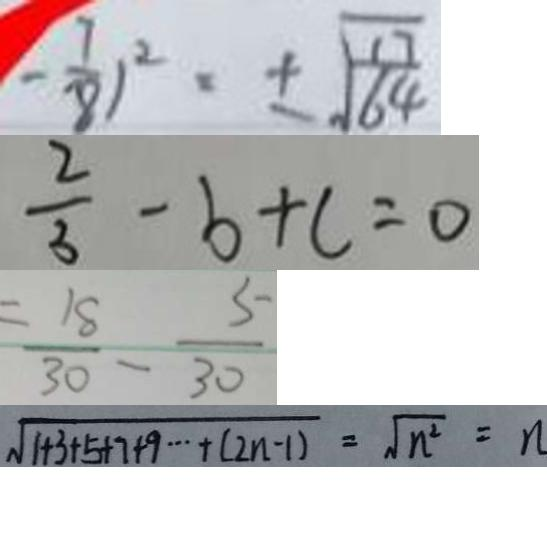<formula> <loc_0><loc_0><loc_500><loc_500>- \frac { 7 } { 8 } ) ^ { 2 } = \pm \sqrt { \frac { 1 7 } { 6 4 } } 
 \frac { 2 } { 3 } - b + c = 0 
 = \frac { 1 8 } { 3 0 } - \frac { 5 } { 3 0 } 
 \sqrt { 1 + 3 + 5 + 7 + 9 \cdots + ( 2 n - 1 ) } = \sqrt { n ^ { 2 } } = n</formula> 